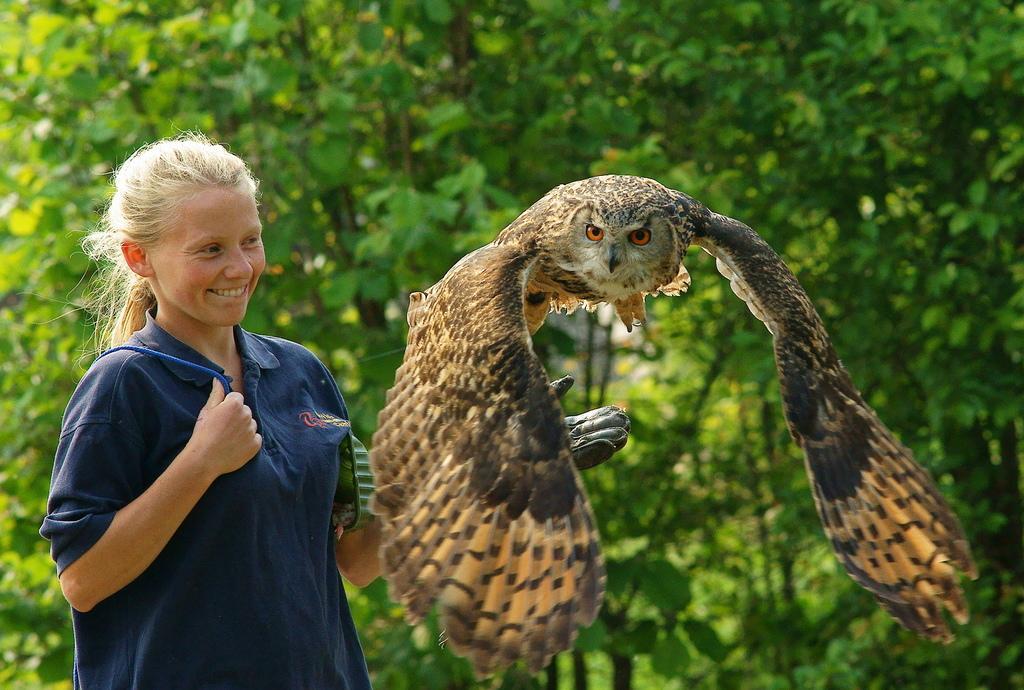In one or two sentences, can you explain what this image depicts? In this image, we can see a lady wearing glove and carrying an object. In the background, there are trees and we can see an owl. 